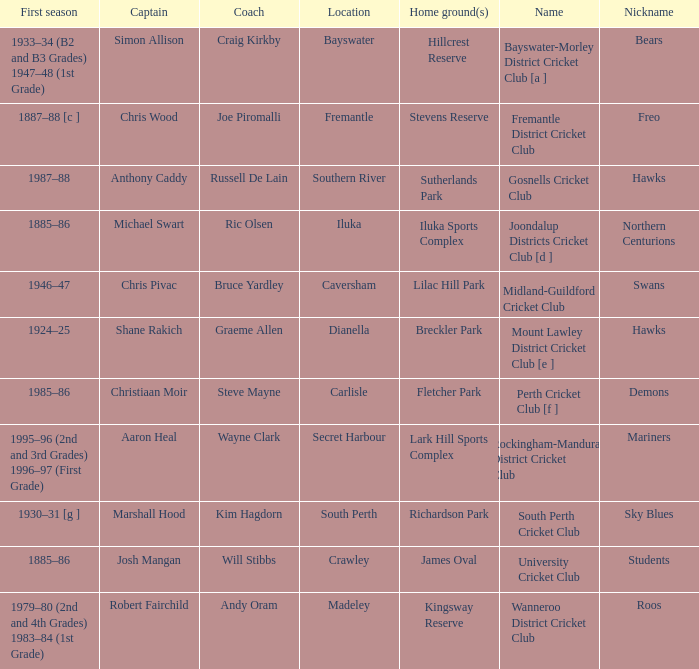What is the code nickname where Steve Mayne is the coach? Demons. 